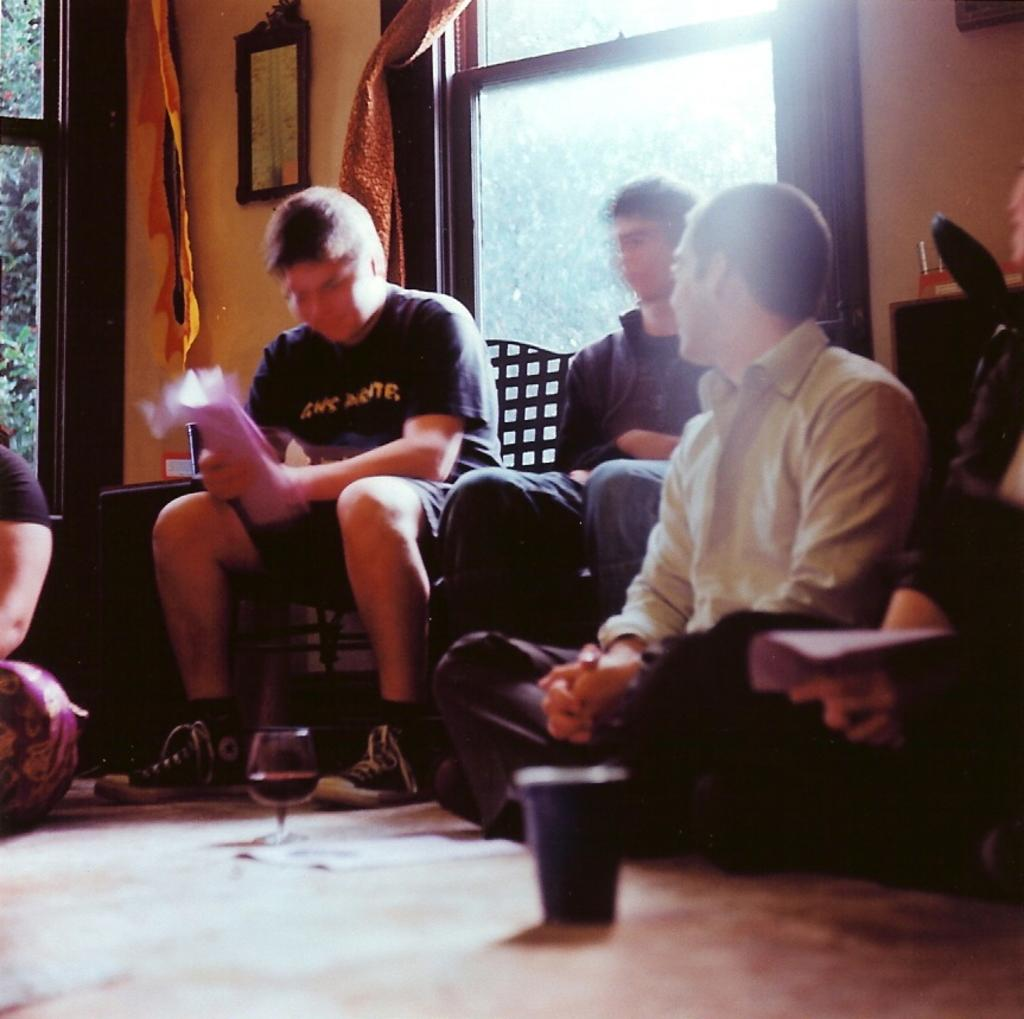What are the people in the image doing? The people in the image are seated, either on chairs or on the floor. What objects are in front of the seated people? There are glasses in front of the seated people. What can be seen in the background of the image? There are trees in the background of the image. What type of bean is being discussed by the people seated on the floor in the image? There is no bean or discussion about beans present in the image. 